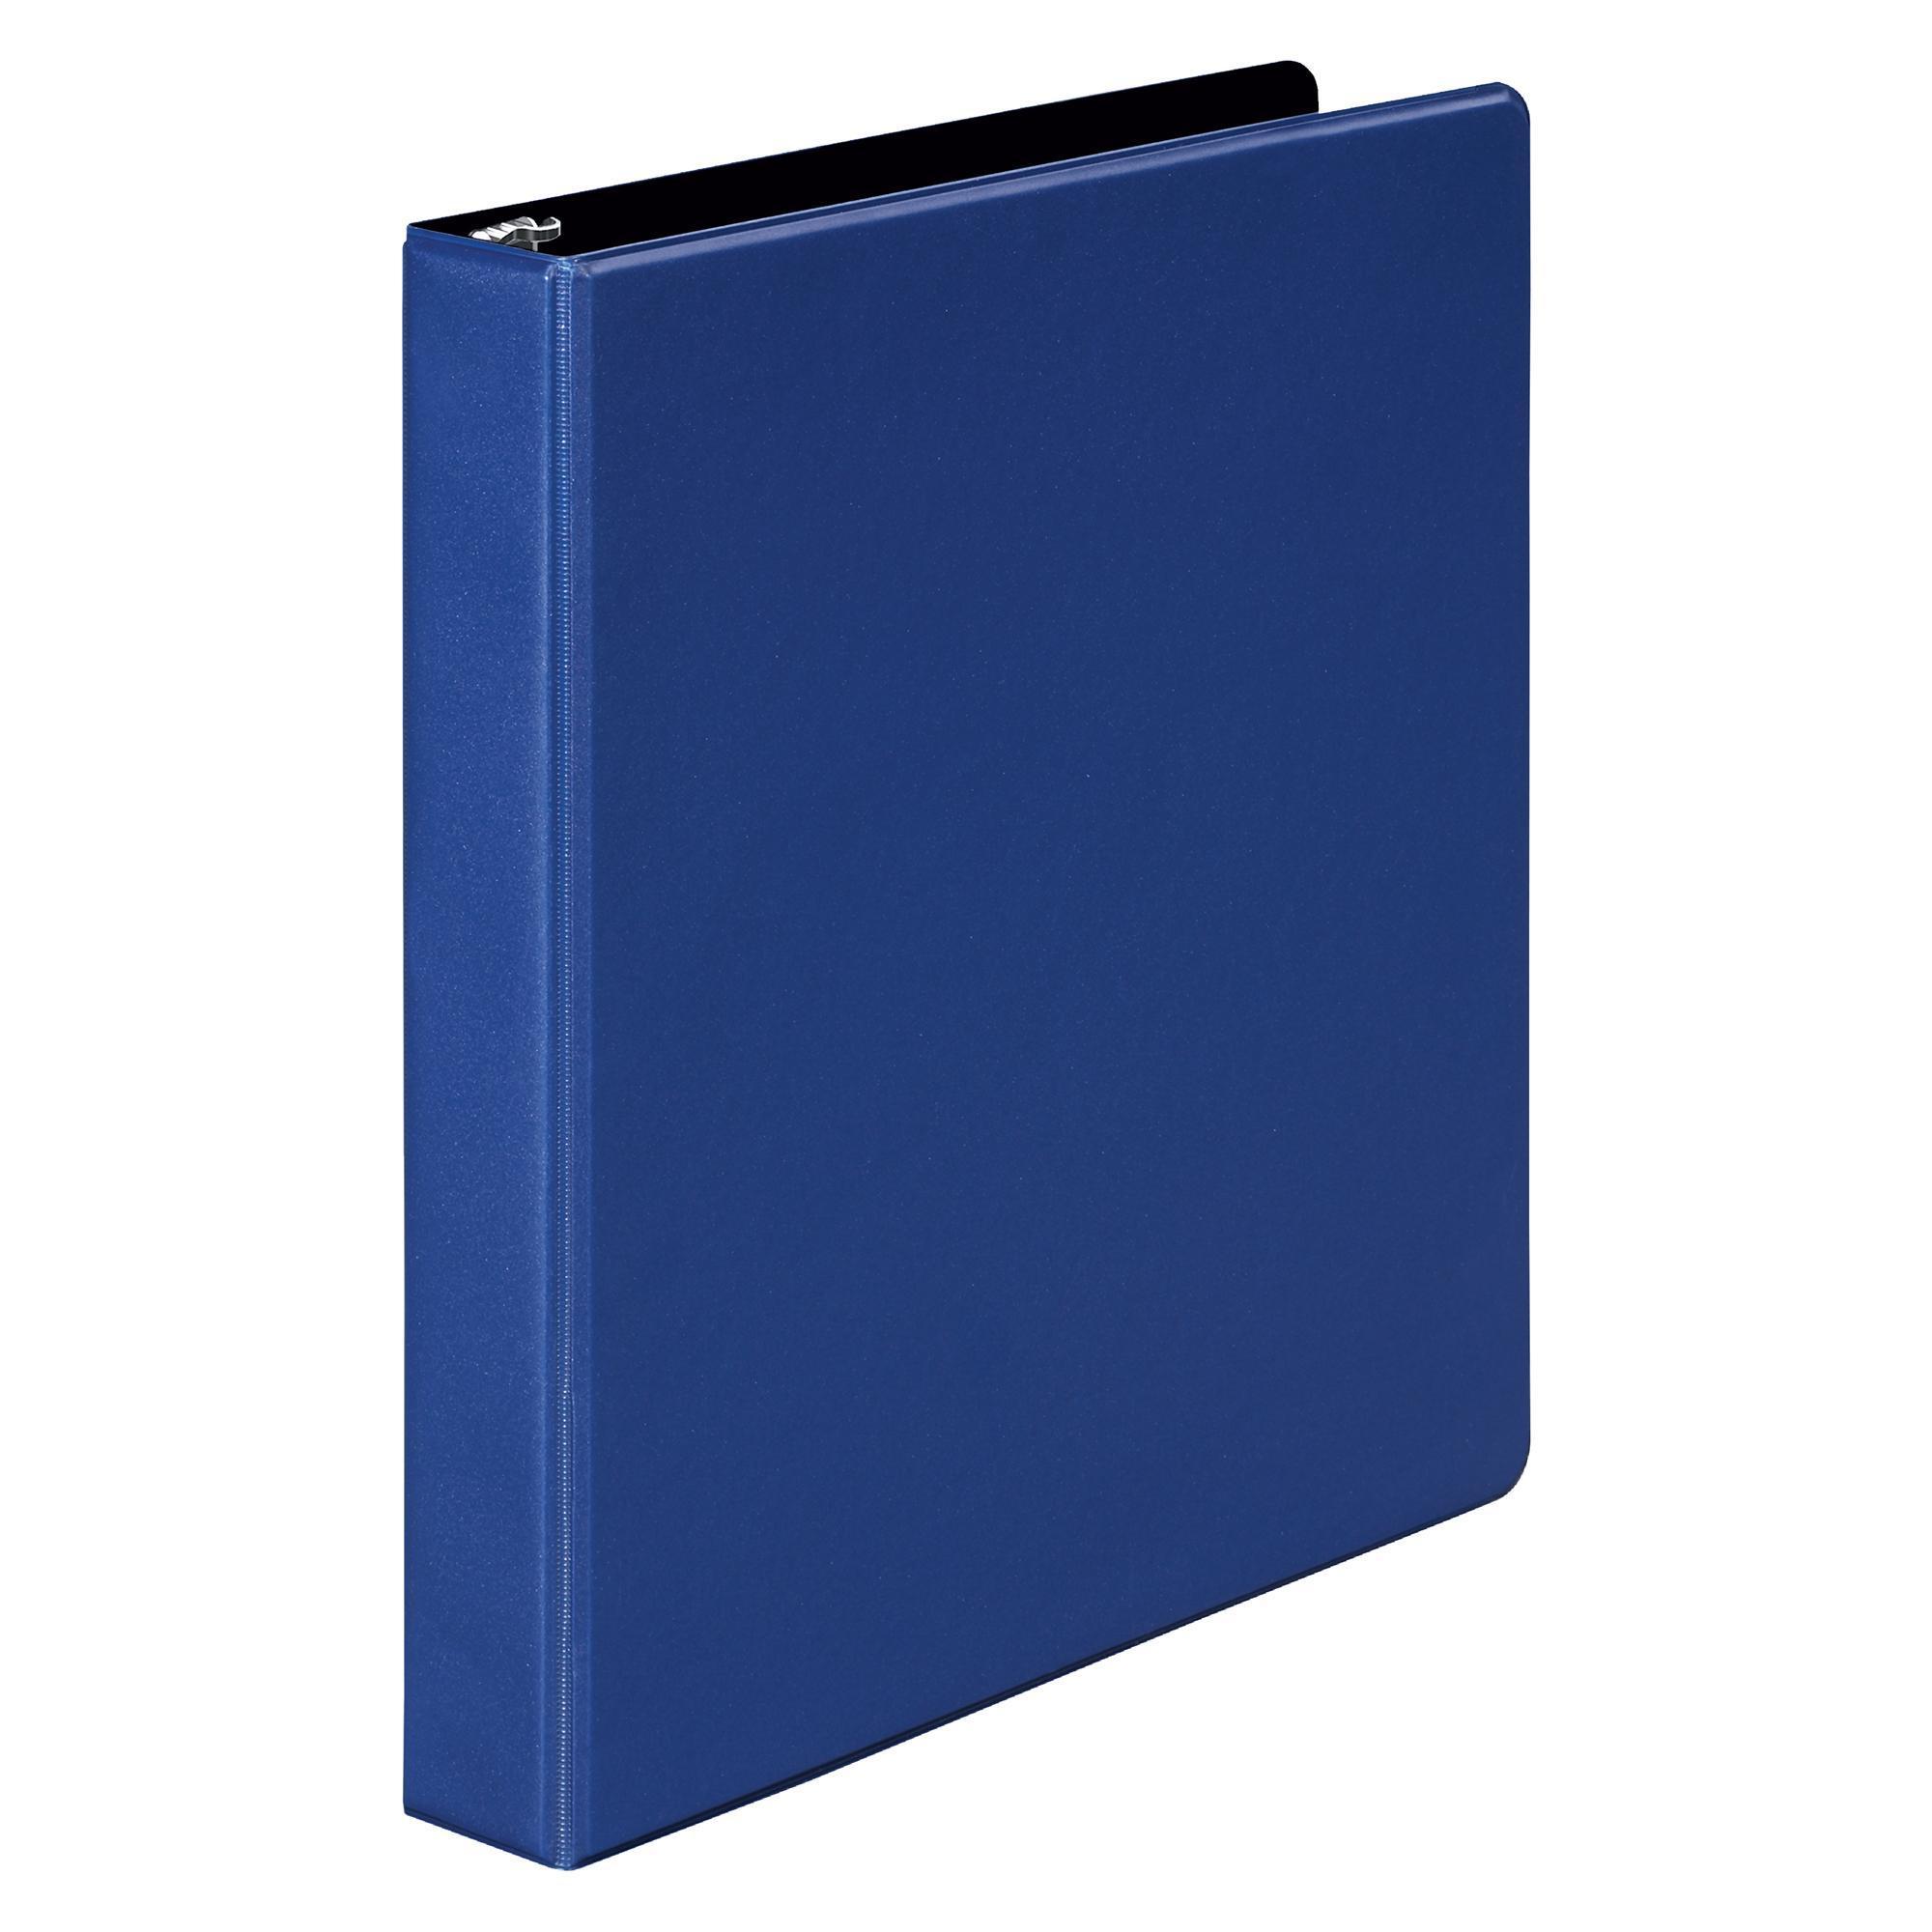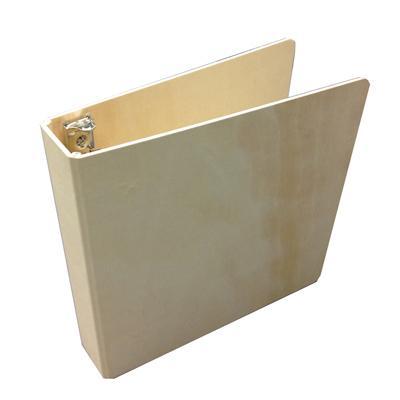The first image is the image on the left, the second image is the image on the right. For the images shown, is this caption "One of the binders is solid blue." true? Answer yes or no. Yes. The first image is the image on the left, the second image is the image on the right. Assess this claim about the two images: "There are at least three binders.". Correct or not? Answer yes or no. No. 